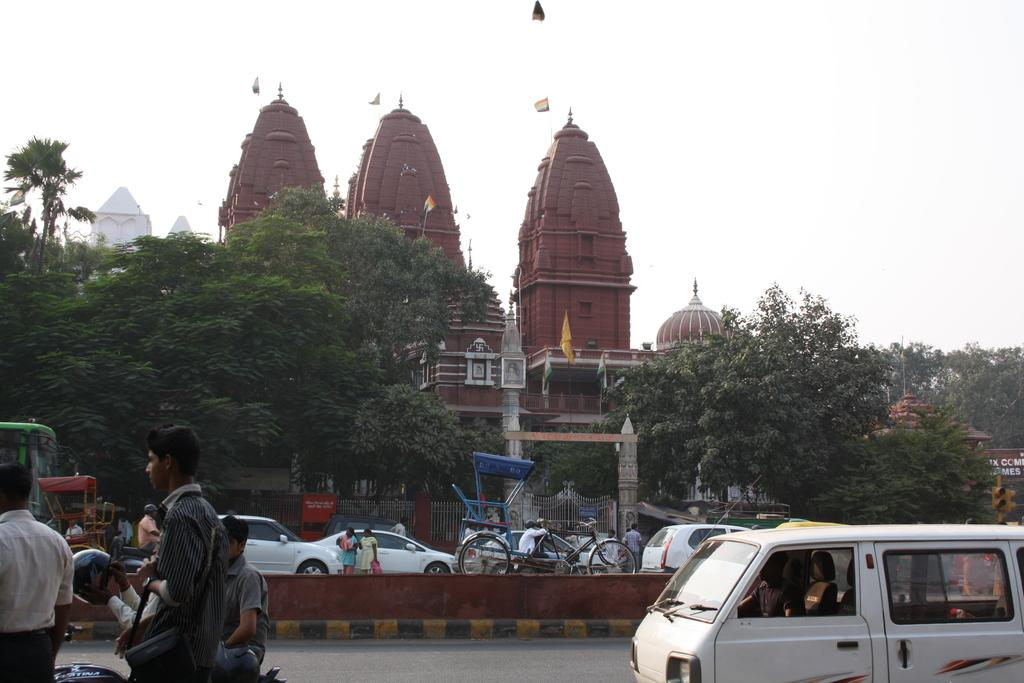What can be seen on the road in the image? There are vehicles on the road in the image. What else is happening on the road? People are walking on the road. What can be seen in the background of the image? There are trees and a building visible in the background. What is on top of the building? There is a flag on top of the building. Can you find the card that was left on the building's doorstep in the image? There is no card mentioned or visible in the image. What items are on the list that the people are carrying while walking on the road? There is no list mentioned or visible in the image. 